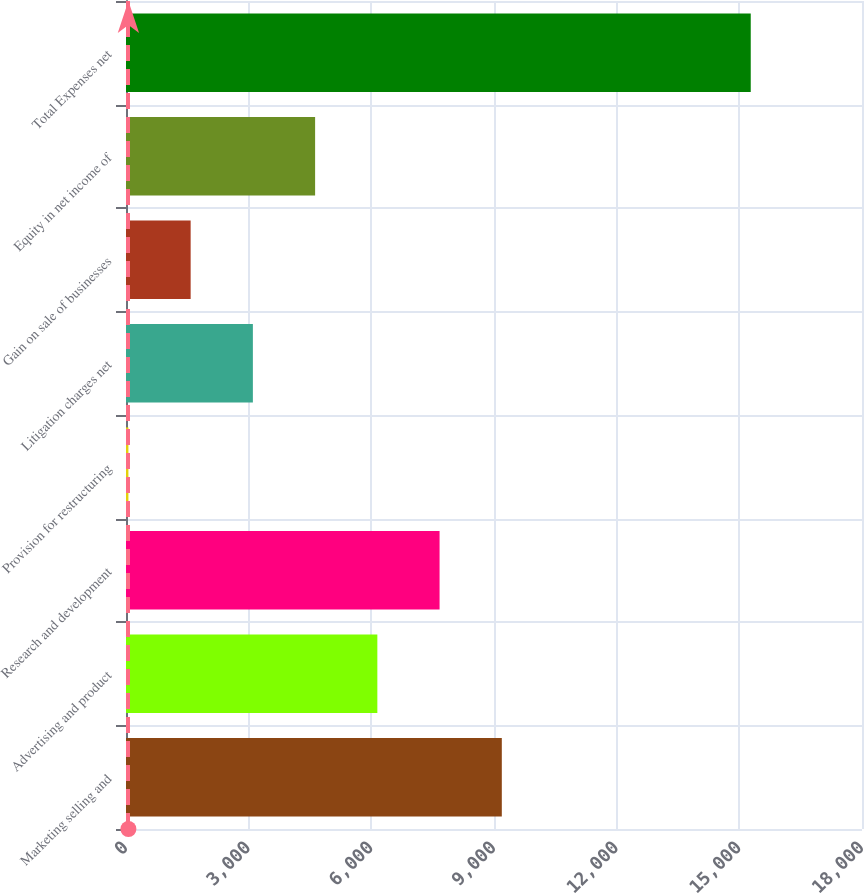Convert chart. <chart><loc_0><loc_0><loc_500><loc_500><bar_chart><fcel>Marketing selling and<fcel>Advertising and product<fcel>Research and development<fcel>Provision for restructuring<fcel>Litigation charges net<fcel>Gain on sale of businesses<fcel>Equity in net income of<fcel>Total Expenses net<nl><fcel>9191<fcel>6147<fcel>7669<fcel>59<fcel>3103<fcel>1581<fcel>4625<fcel>15279<nl></chart> 